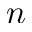<formula> <loc_0><loc_0><loc_500><loc_500>n</formula> 